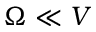<formula> <loc_0><loc_0><loc_500><loc_500>\Omega \ll V</formula> 